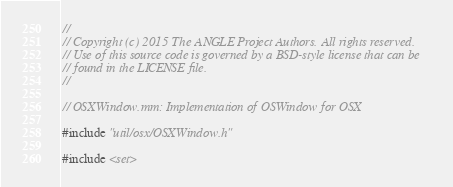Convert code to text. <code><loc_0><loc_0><loc_500><loc_500><_ObjectiveC_>//
// Copyright (c) 2015 The ANGLE Project Authors. All rights reserved.
// Use of this source code is governed by a BSD-style license that can be
// found in the LICENSE file.
//

// OSXWindow.mm: Implementation of OSWindow for OSX

#include "util/osx/OSXWindow.h"

#include <set></code> 